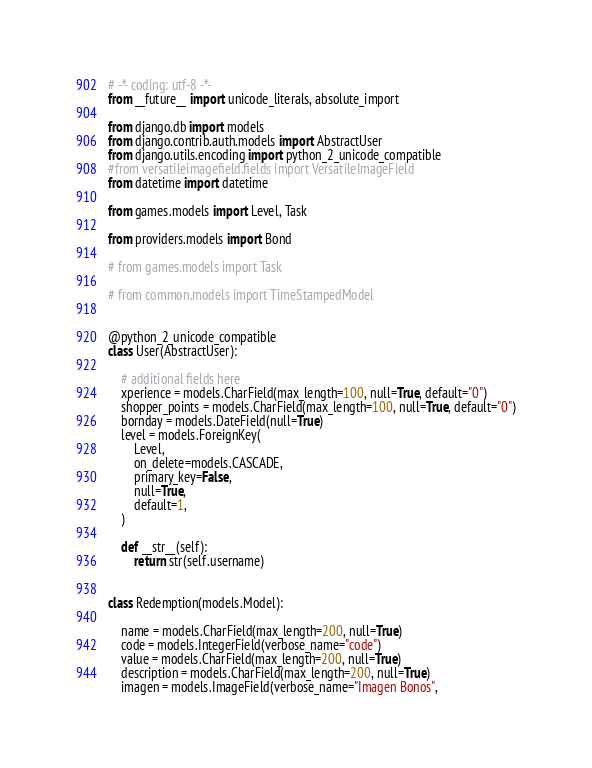<code> <loc_0><loc_0><loc_500><loc_500><_Python_># -*- coding: utf-8 -*-
from __future__ import unicode_literals, absolute_import

from django.db import models
from django.contrib.auth.models import AbstractUser
from django.utils.encoding import python_2_unicode_compatible
#from versatileimagefield.fields import VersatileImageField
from datetime import datetime

from games.models import Level, Task

from providers.models import Bond

# from games.models import Task

# from common.models import TimeStampedModel


@python_2_unicode_compatible
class User(AbstractUser):

    # additional fields here
    xperience = models.CharField(max_length=100, null=True, default="0")
    shopper_points = models.CharField(max_length=100, null=True, default="0")
    bornday = models.DateField(null=True)
    level = models.ForeignKey(
        Level,
        on_delete=models.CASCADE,
        primary_key=False,
        null=True,
        default=1,
    )

    def __str__(self):
        return str(self.username)


class Redemption(models.Model):

    name = models.CharField(max_length=200, null=True)
    code = models.IntegerField(verbose_name="code")
    value = models.CharField(max_length=200, null=True)
    description = models.CharField(max_length=200, null=True)
    imagen = models.ImageField(verbose_name="Imagen Bonos",</code> 